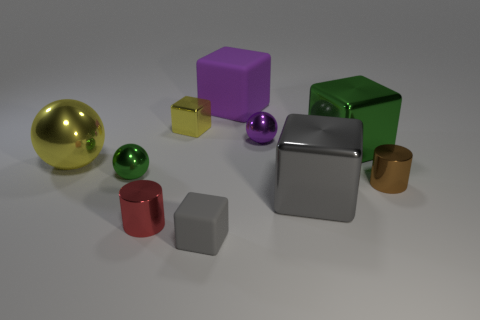Describe the lighting and shadows in the scene. The lighting in the image seems to be coming from above, casting subtle yet distinct shadows directly beneath each object. The strength of the shadows corresponds to the objects' opaqueness and height above the surface, which adds depth and a sense of realism to the scene. The gentle illumination avoids harsh contrasts, preserving detail and creating a calming atmosphere. 